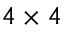<formula> <loc_0><loc_0><loc_500><loc_500>4 \times 4</formula> 